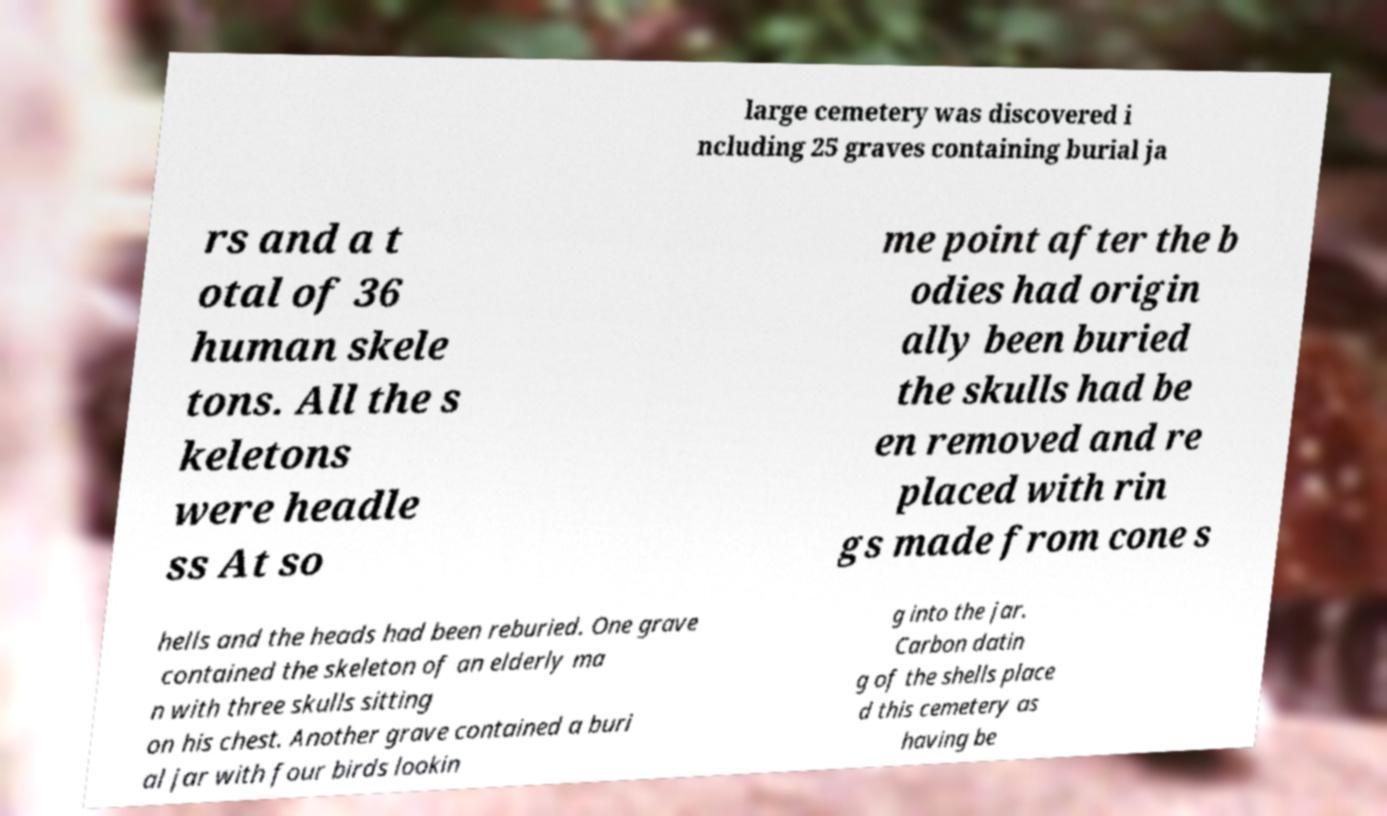There's text embedded in this image that I need extracted. Can you transcribe it verbatim? large cemetery was discovered i ncluding 25 graves containing burial ja rs and a t otal of 36 human skele tons. All the s keletons were headle ss At so me point after the b odies had origin ally been buried the skulls had be en removed and re placed with rin gs made from cone s hells and the heads had been reburied. One grave contained the skeleton of an elderly ma n with three skulls sitting on his chest. Another grave contained a buri al jar with four birds lookin g into the jar. Carbon datin g of the shells place d this cemetery as having be 